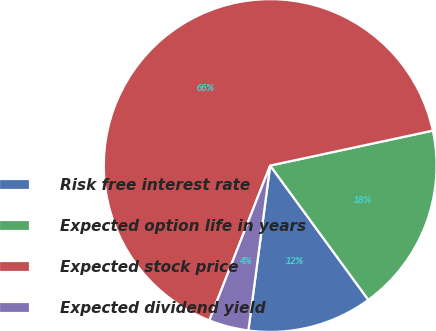Convert chart to OTSL. <chart><loc_0><loc_0><loc_500><loc_500><pie_chart><fcel>Risk free interest rate<fcel>Expected option life in years<fcel>Expected stock price<fcel>Expected dividend yield<nl><fcel>12.14%<fcel>18.32%<fcel>65.67%<fcel>3.86%<nl></chart> 